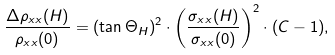Convert formula to latex. <formula><loc_0><loc_0><loc_500><loc_500>\frac { \Delta \rho _ { x x } ( H ) } { \rho _ { x x } ( 0 ) } = ( \tan \Theta _ { H } ) ^ { 2 } \cdot \left ( \frac { \sigma _ { x x } ( H ) } { \sigma _ { x x } ( 0 ) } \right ) ^ { 2 } \cdot ( C - 1 ) ,</formula> 